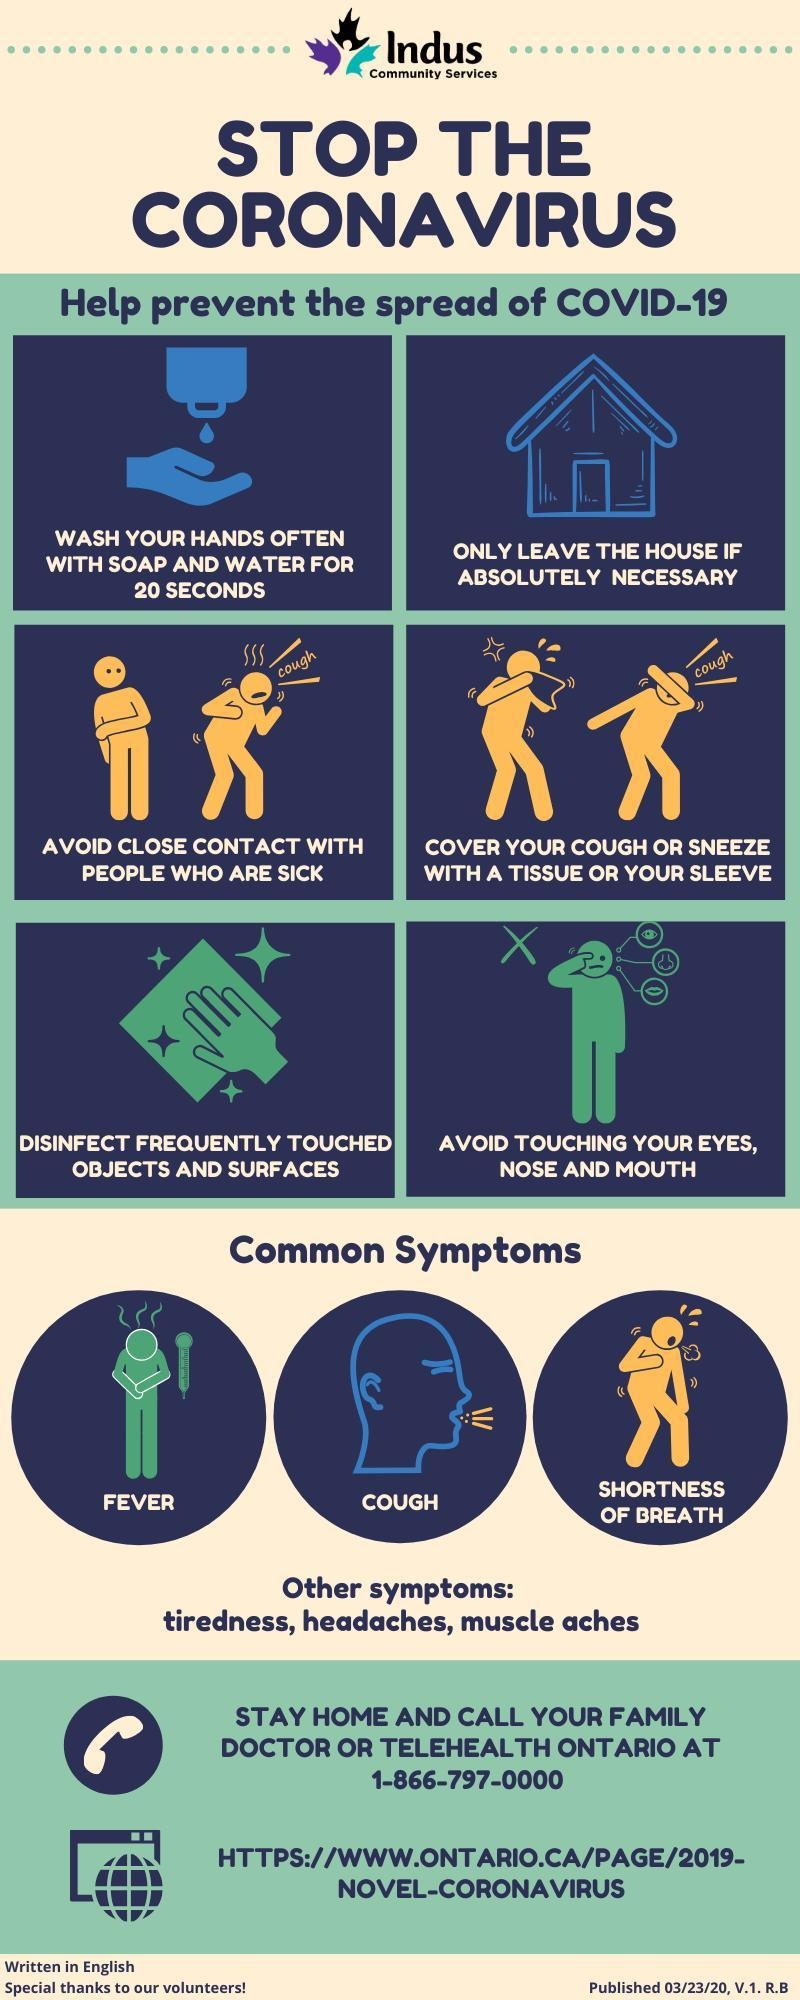What is the third common symptom mentioned?
Answer the question with a short phrase. Shortness of breath What is the fifth step mentioned to prevent the spread of COVID-19? disinfect frequently touched objects and surfaces What is the minimum duration mentioned for hand washing? 20 seconds What is the second step mentioned to prevent the spread of COVID-19? only leave the house if absolutely necessary What is the sixth step mentioned to prevent the spread of COVID-19? Avoid touching your eyes, nose and mouth Besides the three common symptoms, what else might indicate the presence of the coronavirus in body? tiredness, headaches, muscle aches What is the second common symptom mentioned? cough 